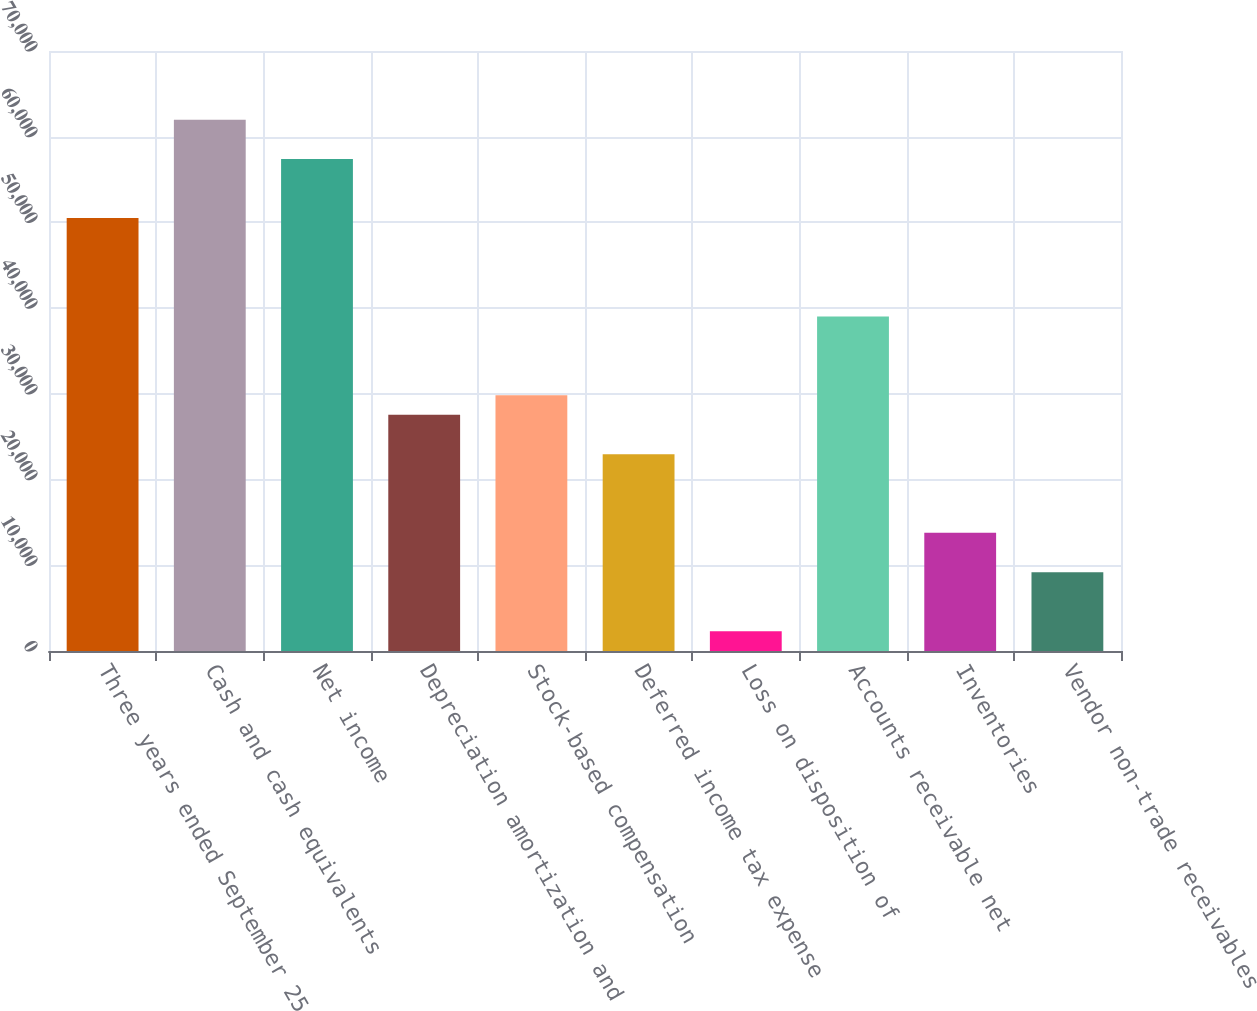Convert chart to OTSL. <chart><loc_0><loc_0><loc_500><loc_500><bar_chart><fcel>Three years ended September 25<fcel>Cash and cash equivalents<fcel>Net income<fcel>Depreciation amortization and<fcel>Stock-based compensation<fcel>Deferred income tax expense<fcel>Loss on disposition of<fcel>Accounts receivable net<fcel>Inventories<fcel>Vendor non-trade receivables<nl><fcel>50511<fcel>61988.5<fcel>57397.5<fcel>27556<fcel>29851.5<fcel>22965<fcel>2305.5<fcel>39033.5<fcel>13783<fcel>9192<nl></chart> 